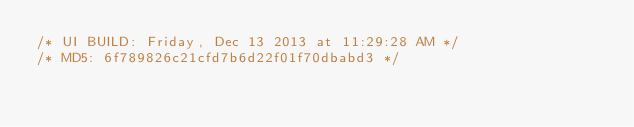<code> <loc_0><loc_0><loc_500><loc_500><_CSS_>/* UI BUILD: Friday, Dec 13 2013 at 11:29:28 AM */
/* MD5: 6f789826c21cfd7b6d22f01f70dbabd3 */
</code> 